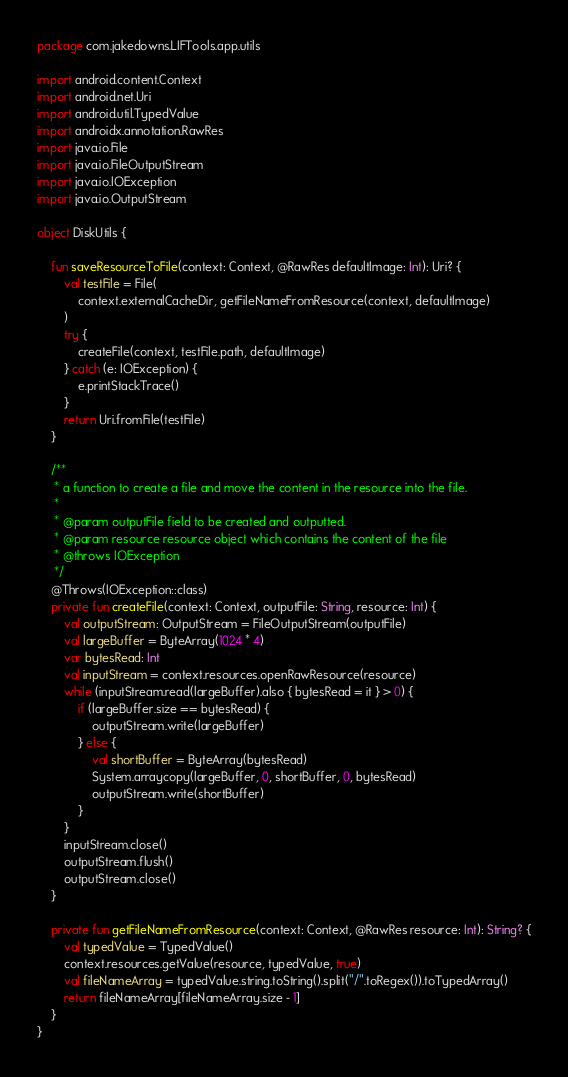Convert code to text. <code><loc_0><loc_0><loc_500><loc_500><_Kotlin_>package com.jakedowns.LIFTools.app.utils

import android.content.Context
import android.net.Uri
import android.util.TypedValue
import androidx.annotation.RawRes
import java.io.File
import java.io.FileOutputStream
import java.io.IOException
import java.io.OutputStream

object DiskUtils {

    fun saveResourceToFile(context: Context, @RawRes defaultImage: Int): Uri? {
        val testFile = File(
            context.externalCacheDir, getFileNameFromResource(context, defaultImage)
        )
        try {
            createFile(context, testFile.path, defaultImage)
        } catch (e: IOException) {
            e.printStackTrace()
        }
        return Uri.fromFile(testFile)
    }

    /**
     * a function to create a file and move the content in the resource into the file.
     *
     * @param outputFile field to be created and outputted.
     * @param resource resource object which contains the content of the file
     * @throws IOException
     */
    @Throws(IOException::class)
    private fun createFile(context: Context, outputFile: String, resource: Int) {
        val outputStream: OutputStream = FileOutputStream(outputFile)
        val largeBuffer = ByteArray(1024 * 4)
        var bytesRead: Int
        val inputStream = context.resources.openRawResource(resource)
        while (inputStream.read(largeBuffer).also { bytesRead = it } > 0) {
            if (largeBuffer.size == bytesRead) {
                outputStream.write(largeBuffer)
            } else {
                val shortBuffer = ByteArray(bytesRead)
                System.arraycopy(largeBuffer, 0, shortBuffer, 0, bytesRead)
                outputStream.write(shortBuffer)
            }
        }
        inputStream.close()
        outputStream.flush()
        outputStream.close()
    }

    private fun getFileNameFromResource(context: Context, @RawRes resource: Int): String? {
        val typedValue = TypedValue()
        context.resources.getValue(resource, typedValue, true)
        val fileNameArray = typedValue.string.toString().split("/".toRegex()).toTypedArray()
        return fileNameArray[fileNameArray.size - 1]
    }
}</code> 